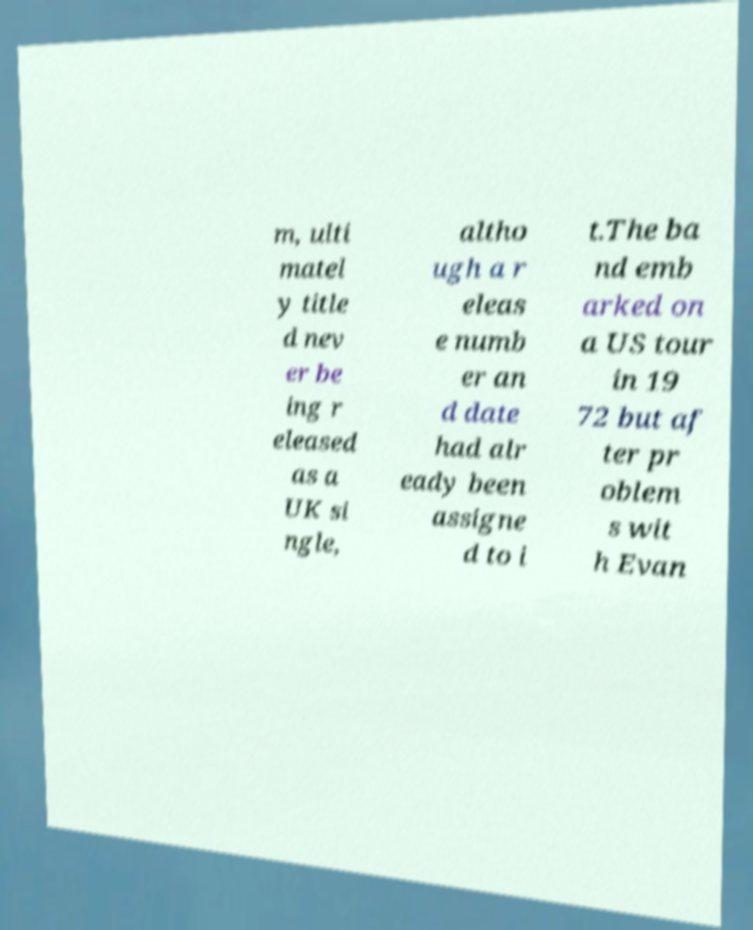For documentation purposes, I need the text within this image transcribed. Could you provide that? m, ulti matel y title d nev er be ing r eleased as a UK si ngle, altho ugh a r eleas e numb er an d date had alr eady been assigne d to i t.The ba nd emb arked on a US tour in 19 72 but af ter pr oblem s wit h Evan 